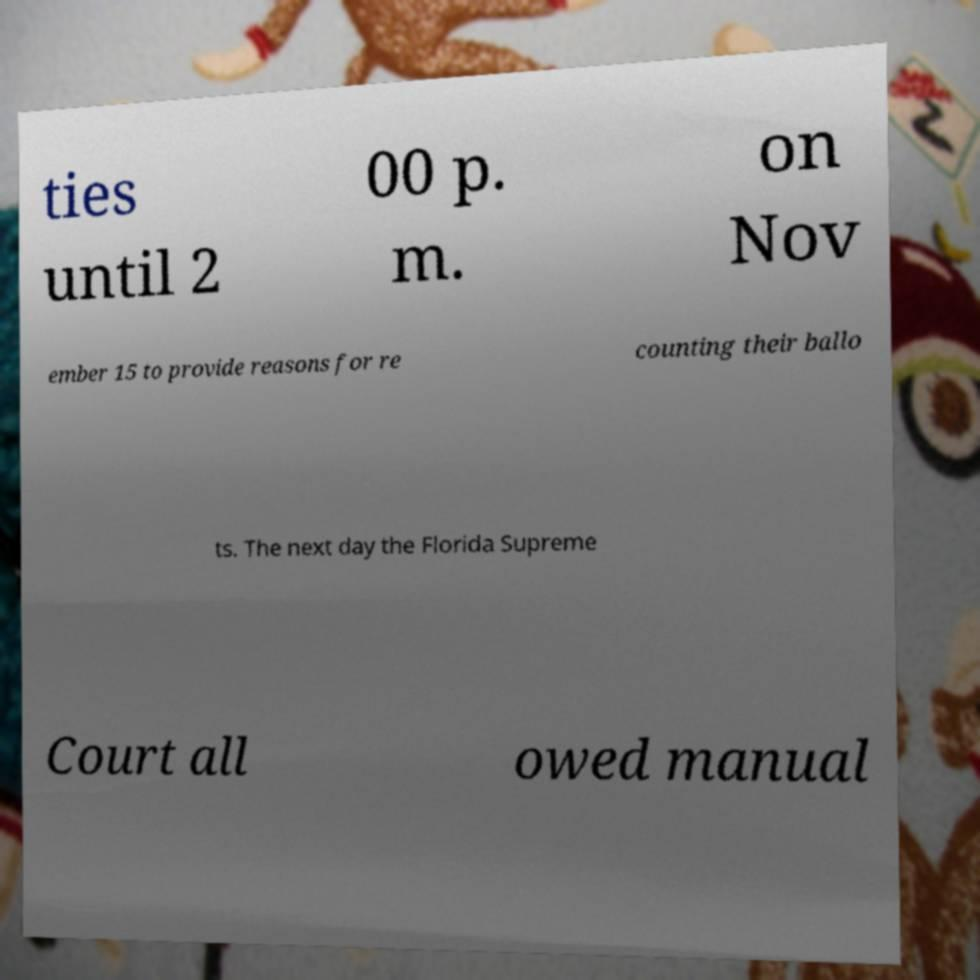Please read and relay the text visible in this image. What does it say? ties until 2 00 p. m. on Nov ember 15 to provide reasons for re counting their ballo ts. The next day the Florida Supreme Court all owed manual 